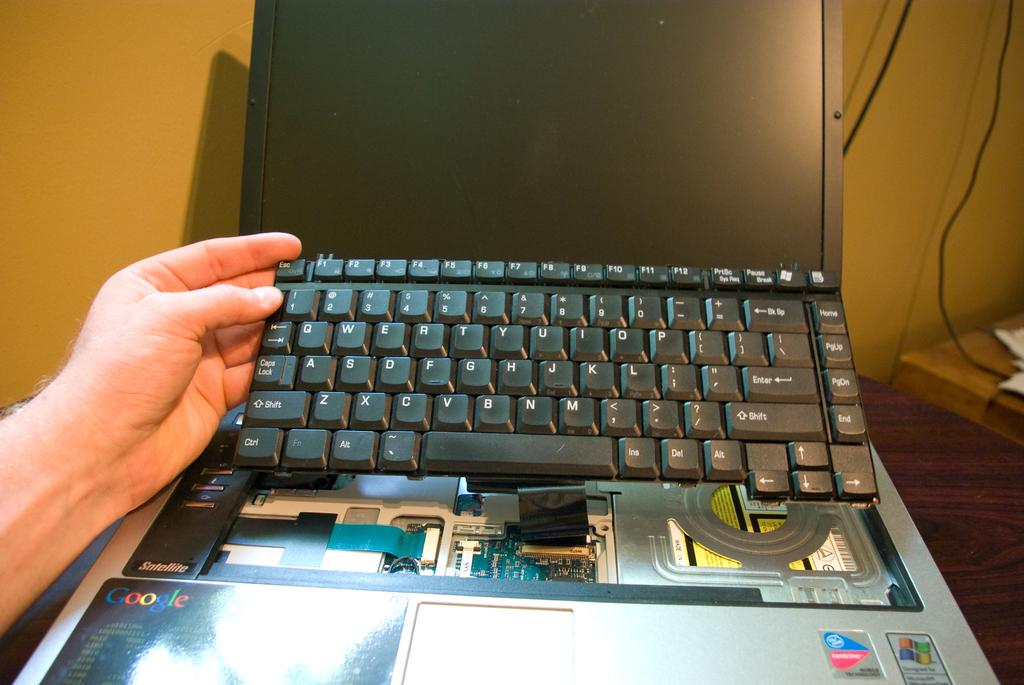<image>
Give a short and clear explanation of the subsequent image. A hand holding up a laptop keyboard with google written on the board. 